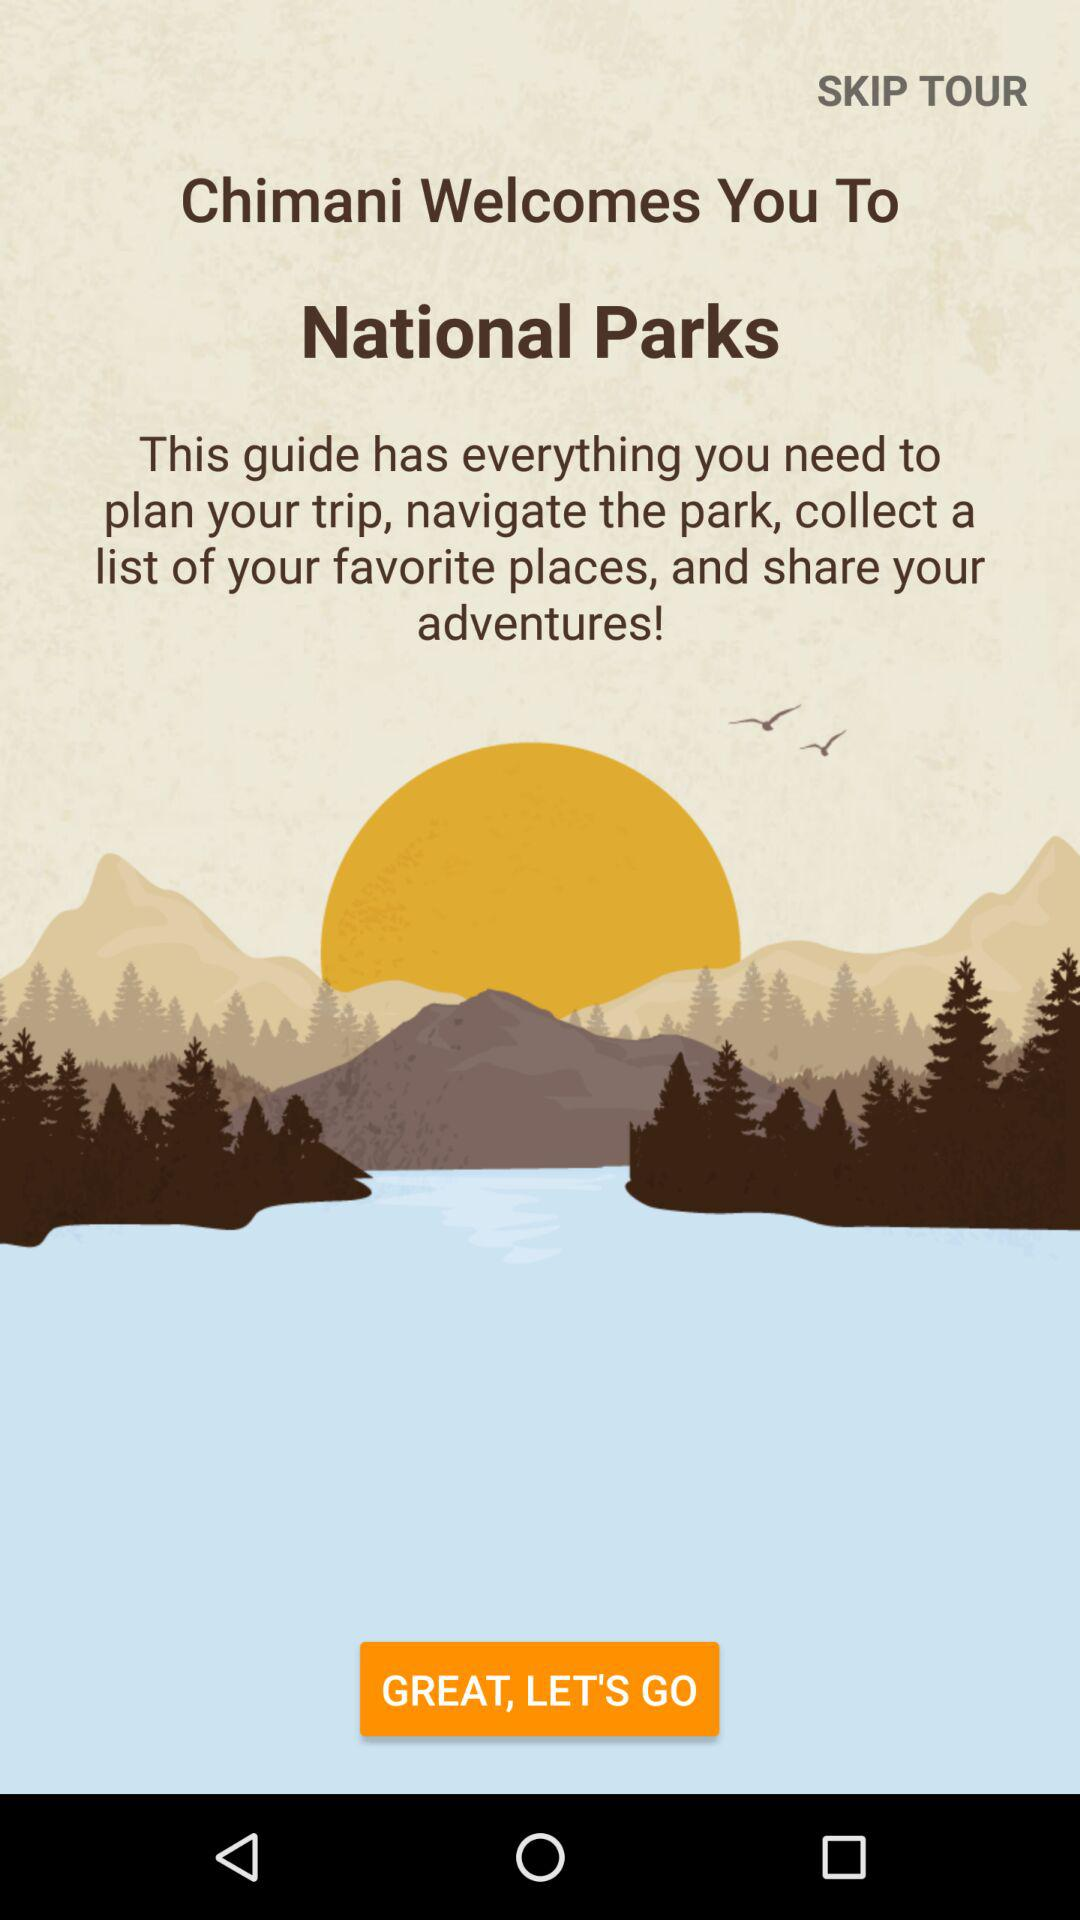What is the application name? The application name is "Chimani". 